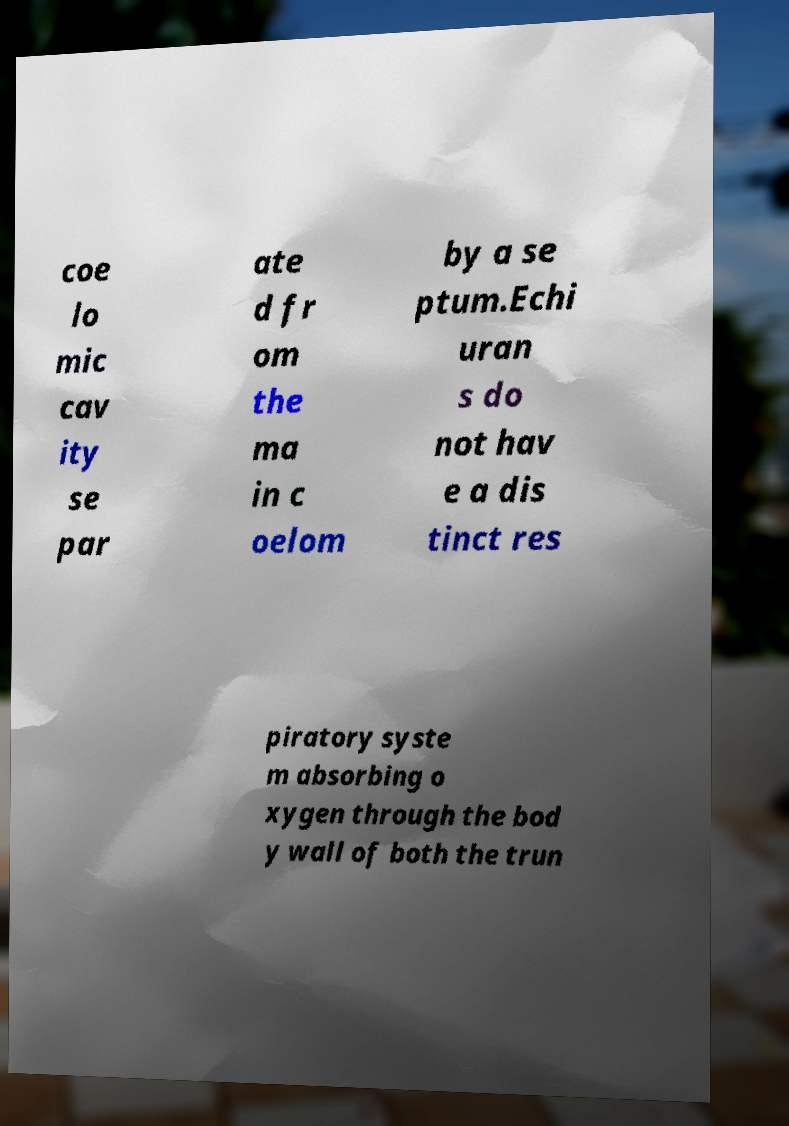Please identify and transcribe the text found in this image. coe lo mic cav ity se par ate d fr om the ma in c oelom by a se ptum.Echi uran s do not hav e a dis tinct res piratory syste m absorbing o xygen through the bod y wall of both the trun 